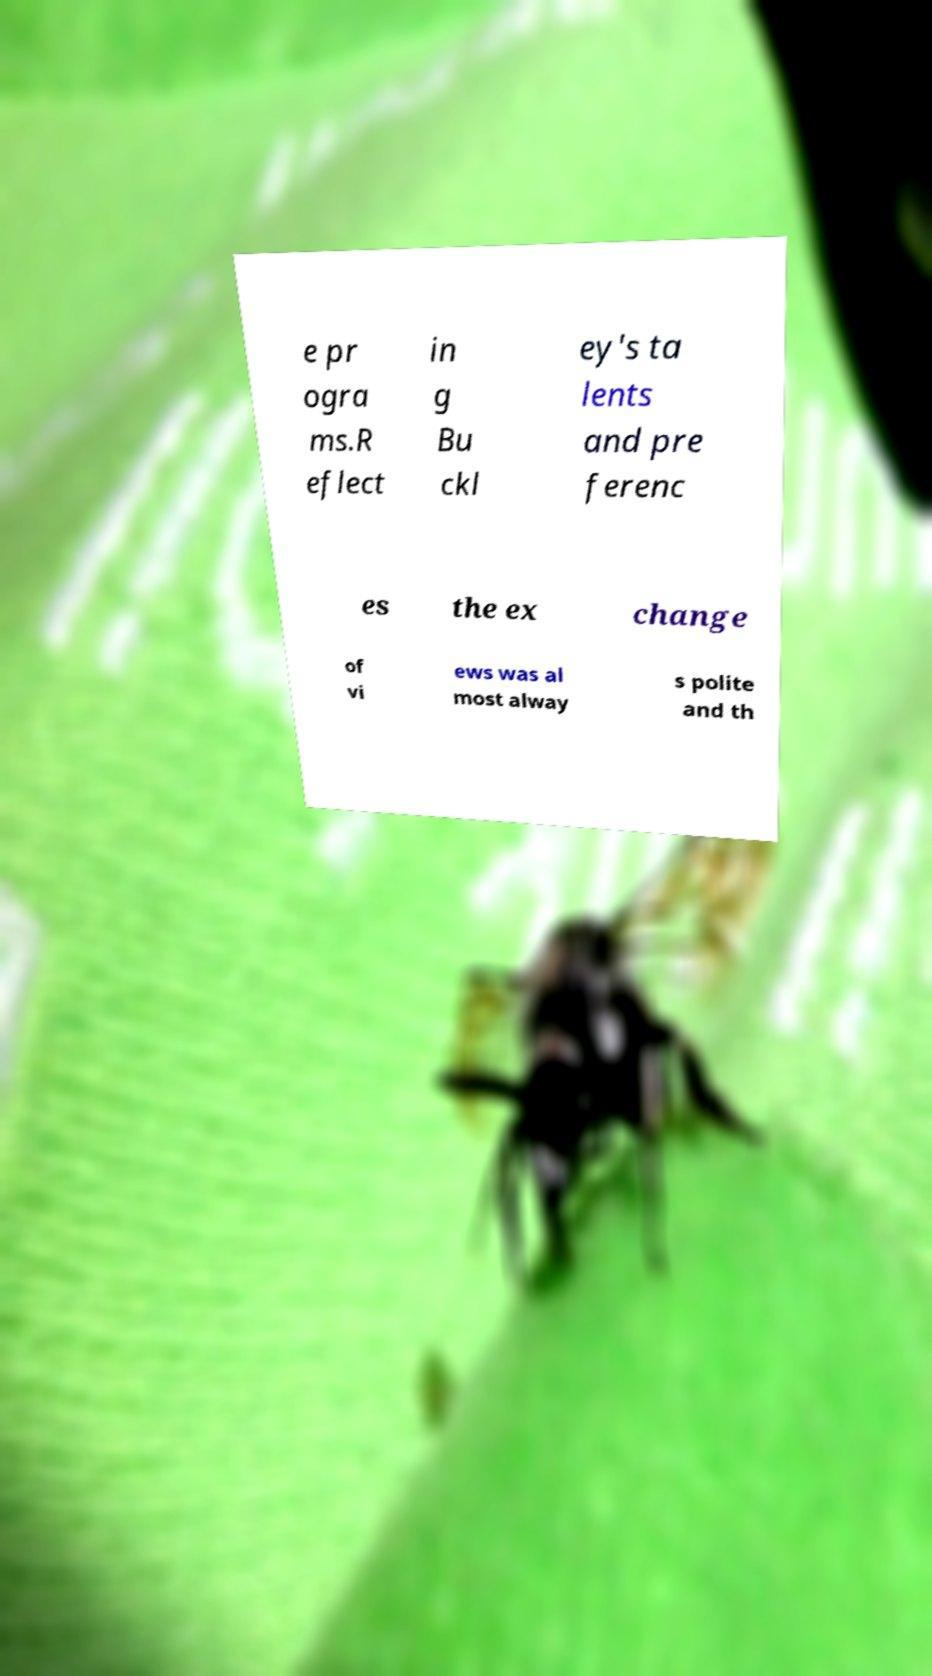Can you accurately transcribe the text from the provided image for me? e pr ogra ms.R eflect in g Bu ckl ey's ta lents and pre ferenc es the ex change of vi ews was al most alway s polite and th 